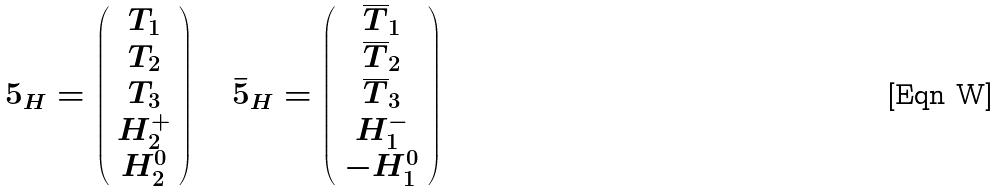<formula> <loc_0><loc_0><loc_500><loc_500>5 _ { H } = \left ( \begin{array} { c } T _ { 1 } \\ T _ { 2 } \\ T _ { 3 } \\ H _ { 2 } ^ { + } \\ H _ { 2 } ^ { 0 } \end{array} \right ) \quad \bar { 5 } _ { H } = \left ( \begin{array} { c } \overline { T } _ { 1 } \\ \overline { T } _ { 2 } \\ \overline { T } _ { 3 } \\ H _ { 1 } ^ { - } \\ - H _ { 1 } ^ { 0 } \end{array} \right )</formula> 